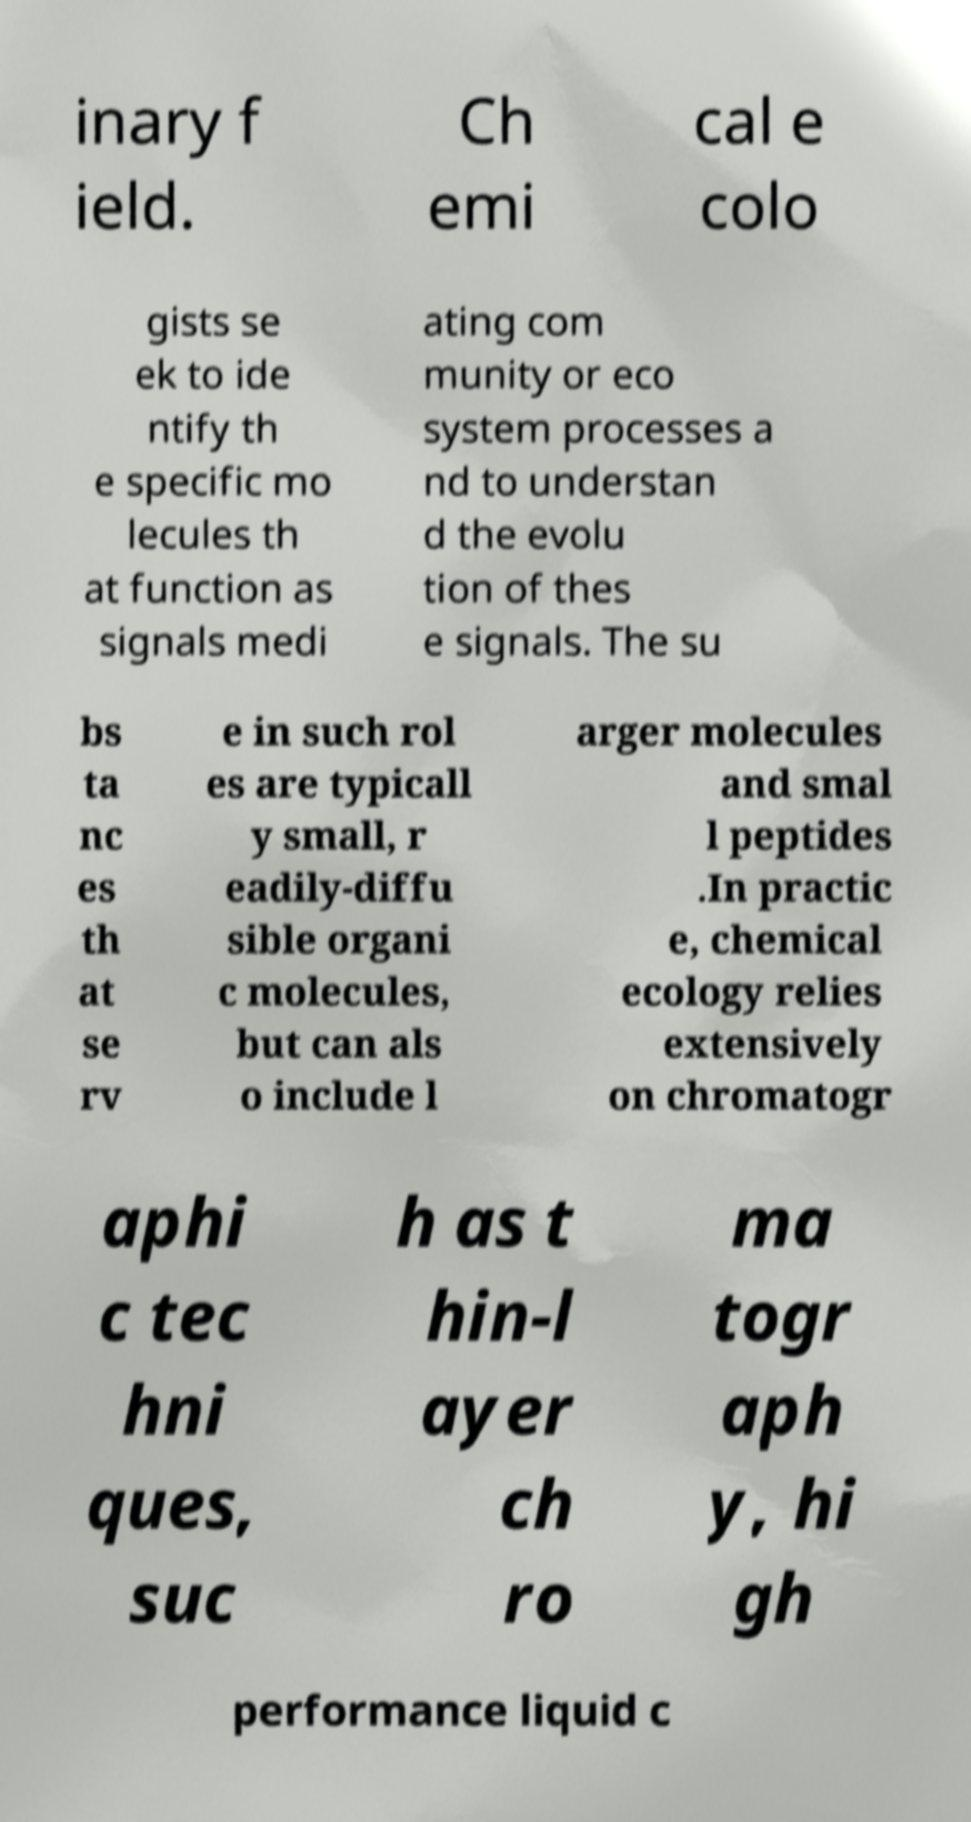There's text embedded in this image that I need extracted. Can you transcribe it verbatim? inary f ield. Ch emi cal e colo gists se ek to ide ntify th e specific mo lecules th at function as signals medi ating com munity or eco system processes a nd to understan d the evolu tion of thes e signals. The su bs ta nc es th at se rv e in such rol es are typicall y small, r eadily-diffu sible organi c molecules, but can als o include l arger molecules and smal l peptides .In practic e, chemical ecology relies extensively on chromatogr aphi c tec hni ques, suc h as t hin-l ayer ch ro ma togr aph y, hi gh performance liquid c 